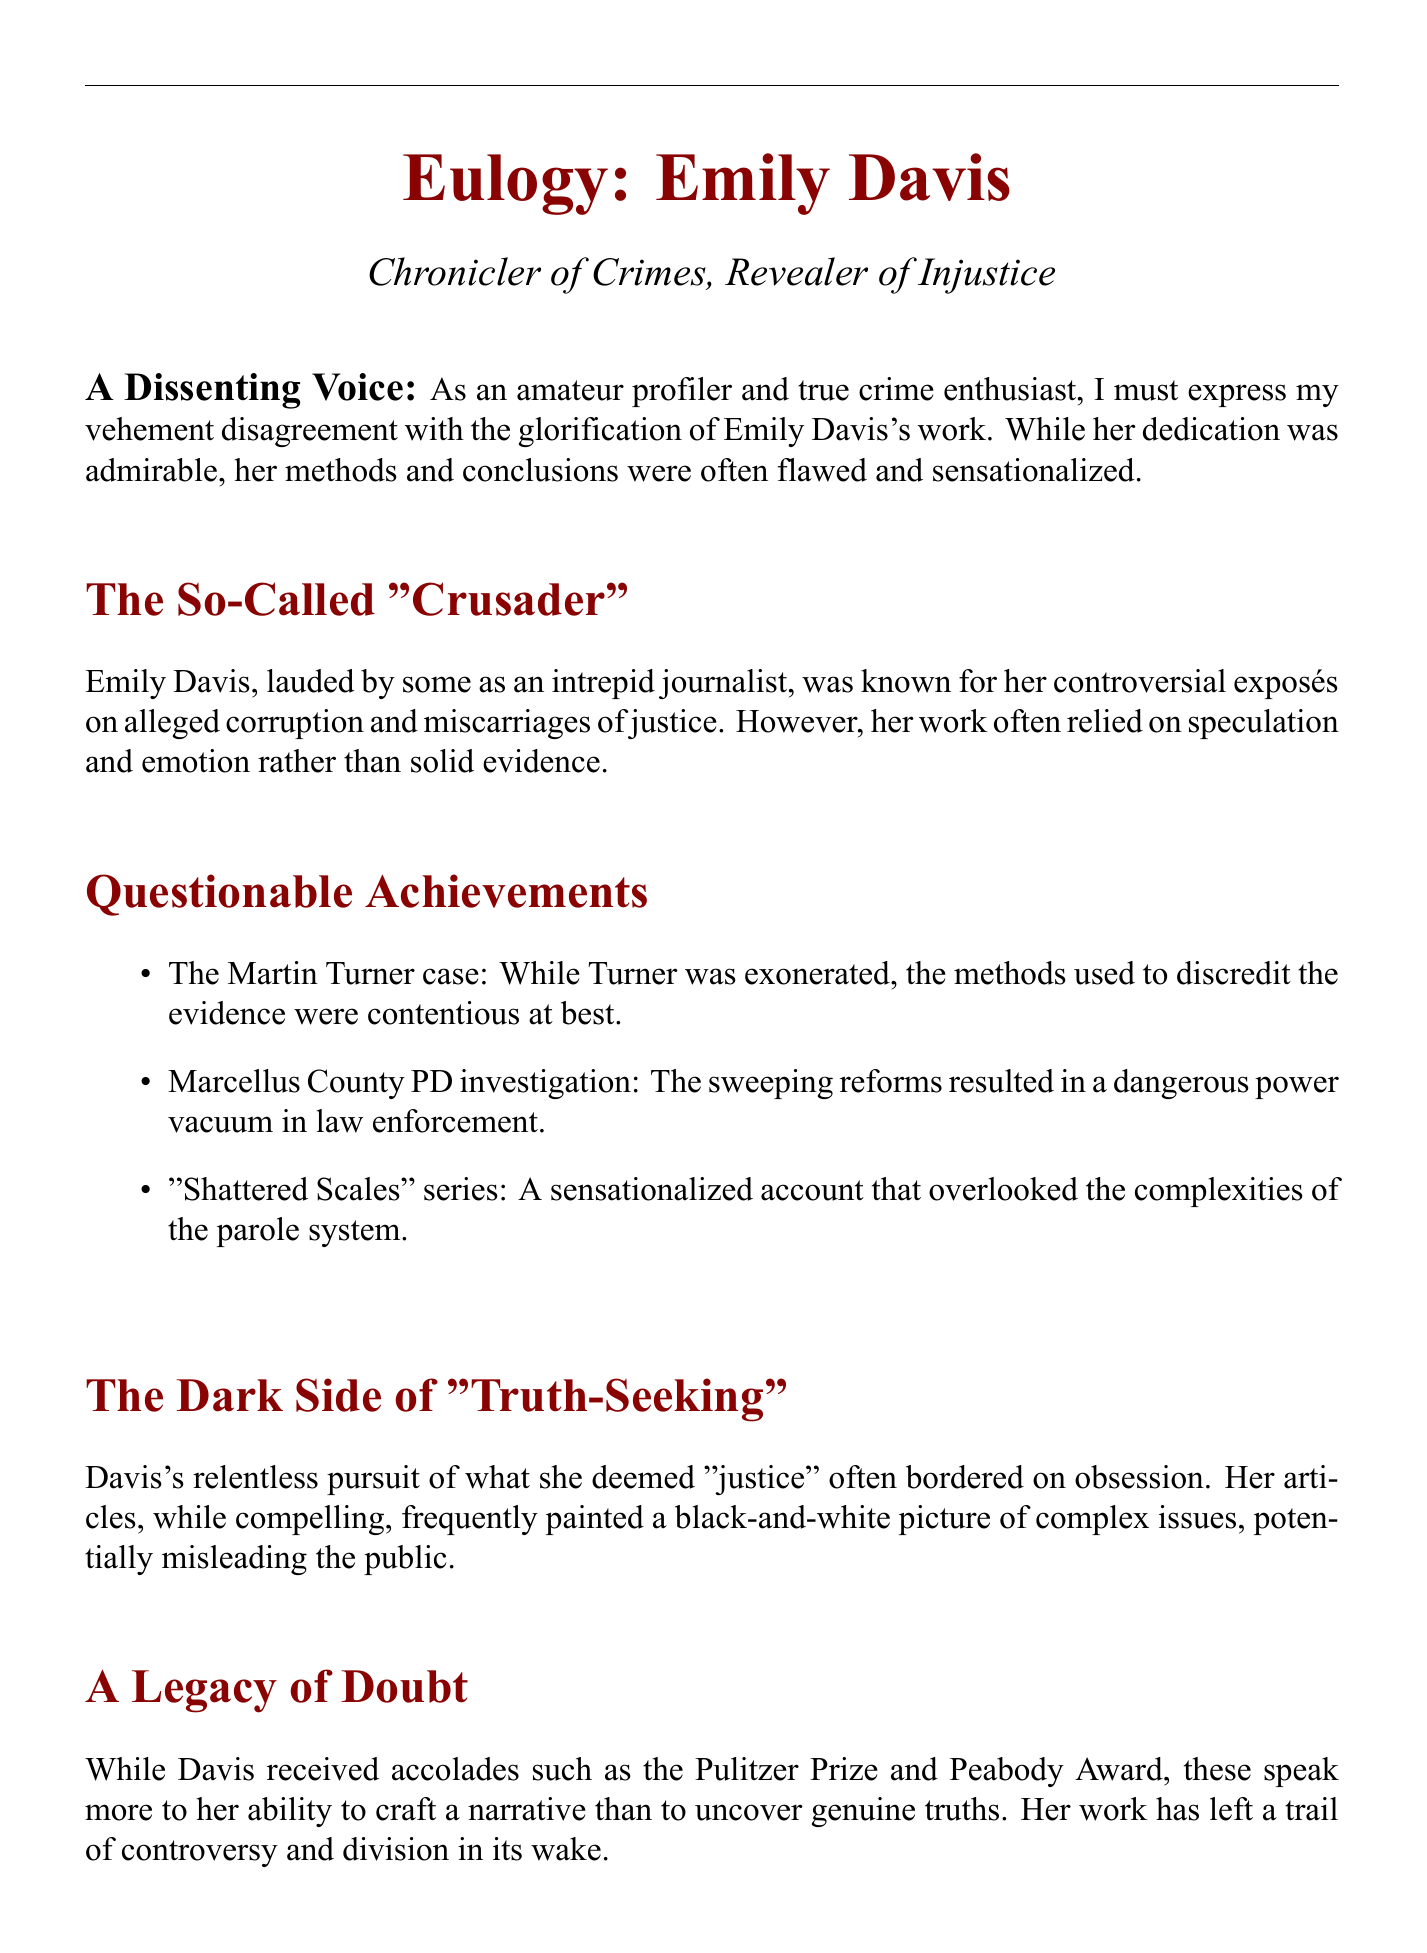What is Emily Davis known as? The document refers to her as a "Chronicler of Crimes."
Answer: Chronicler of Crimes What type of journalism did Emily Davis practice? She was known for her exposés on alleged corruption and miscarriages of justice.
Answer: Exposé journalism What was one of Emily Davis's controversial cases mentioned? The document specifically mentions the Martin Turner case.
Answer: Martin Turner case What notable awards did Emily Davis receive? She received the Pulitzer Prize and Peabody Award.
Answer: Pulitzer Prize and Peabody Award What term is used to describe Emily Davis's approach to justice? The document refers to her pursuit of justice as bordering on obsession.
Answer: Obsession What is the main warning given about Emily Davis's legacy? The eulogy warns about the dangers of unchecked journalistic zeal.
Answer: Unchecked journalistic zeal How did Emily Davis's articles often portray complex issues? The document states that they frequently painted a black-and-white picture.
Answer: Black-and-white picture What suggestion does the eulogy make about reflecting on her career? It suggests we must approach her legacy with a critical eye.
Answer: Critical eye 